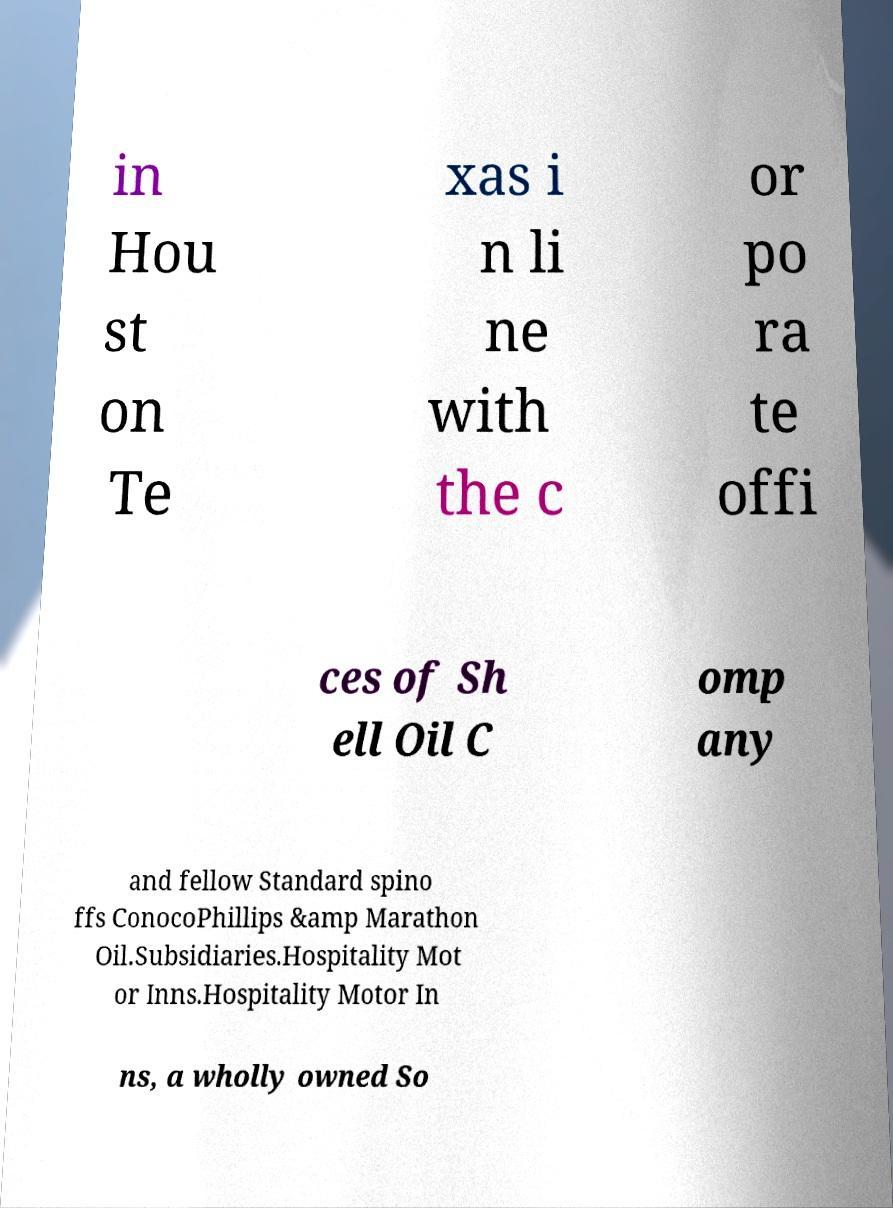Can you accurately transcribe the text from the provided image for me? in Hou st on Te xas i n li ne with the c or po ra te offi ces of Sh ell Oil C omp any and fellow Standard spino ffs ConocoPhillips &amp Marathon Oil.Subsidiaries.Hospitality Mot or Inns.Hospitality Motor In ns, a wholly owned So 